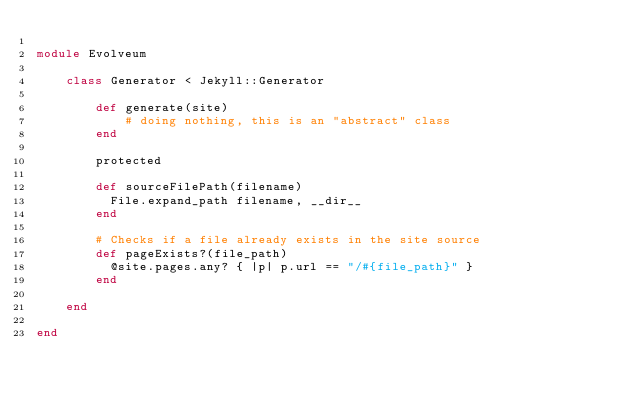<code> <loc_0><loc_0><loc_500><loc_500><_Ruby_>
module Evolveum

    class Generator < Jekyll::Generator

        def generate(site)
            # doing nothing, this is an "abstract" class
        end

        protected

        def sourceFilePath(filename)
          File.expand_path filename, __dir__
        end

        # Checks if a file already exists in the site source
        def pageExists?(file_path)
          @site.pages.any? { |p| p.url == "/#{file_path}" }
        end

    end

end
</code> 